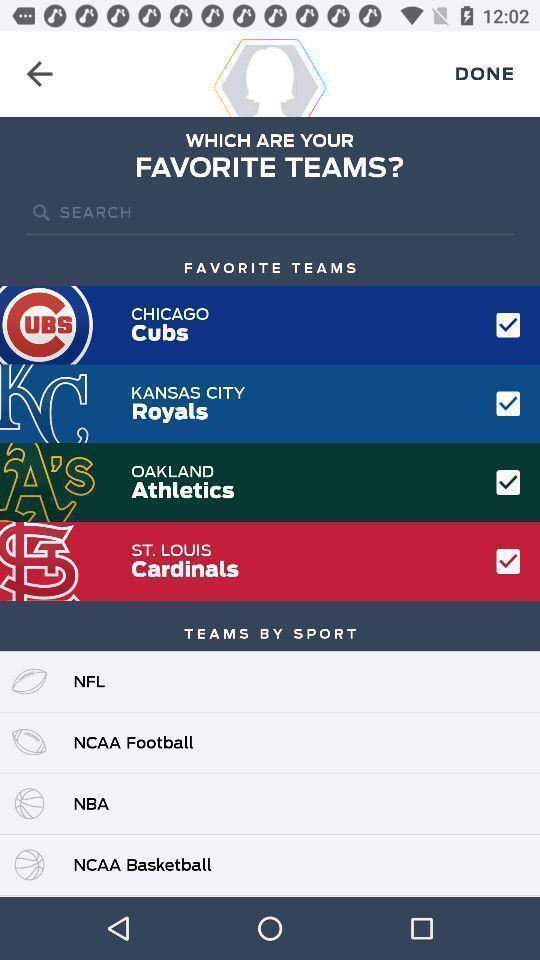Give me a summary of this screen capture. Screen page of a sports application. 